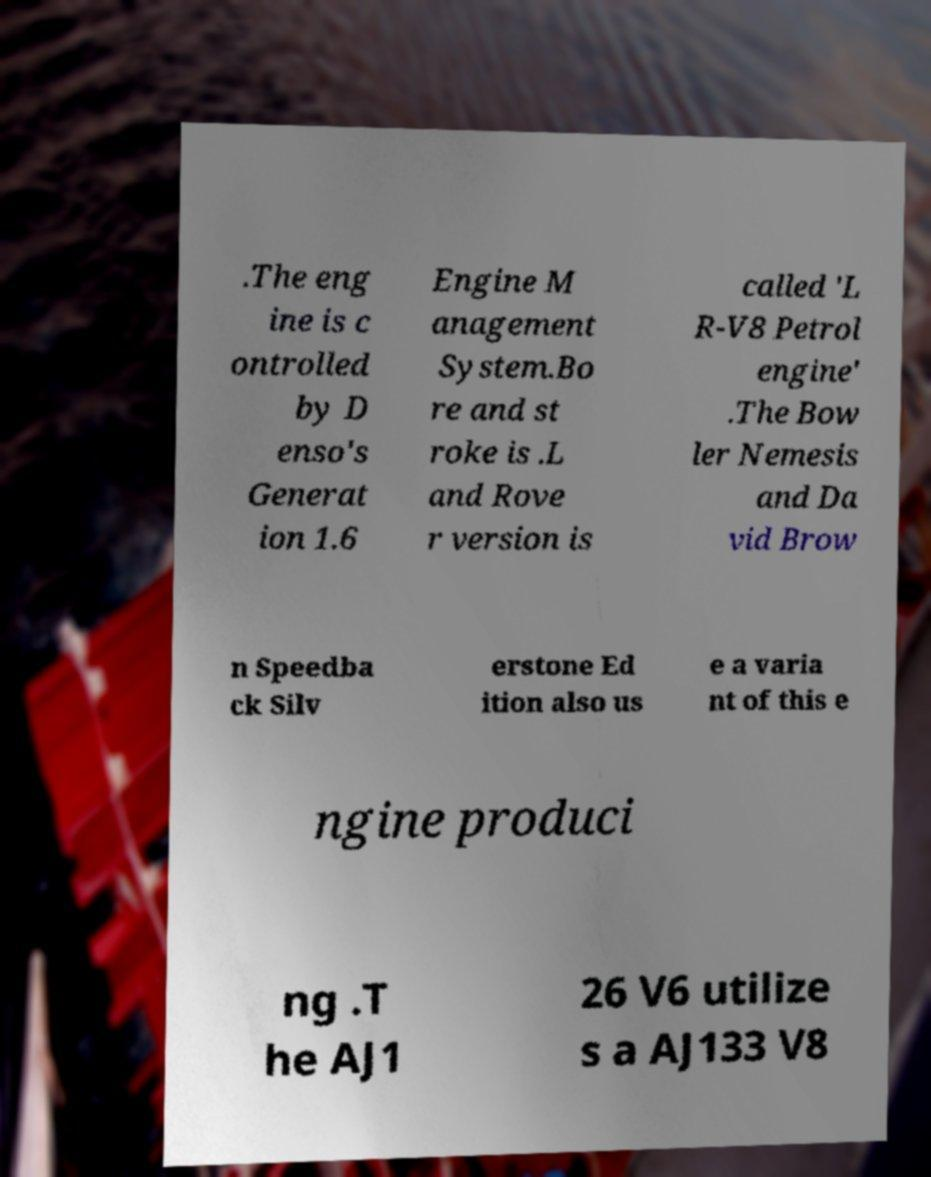Please read and relay the text visible in this image. What does it say? .The eng ine is c ontrolled by D enso's Generat ion 1.6 Engine M anagement System.Bo re and st roke is .L and Rove r version is called 'L R-V8 Petrol engine' .The Bow ler Nemesis and Da vid Brow n Speedba ck Silv erstone Ed ition also us e a varia nt of this e ngine produci ng .T he AJ1 26 V6 utilize s a AJ133 V8 